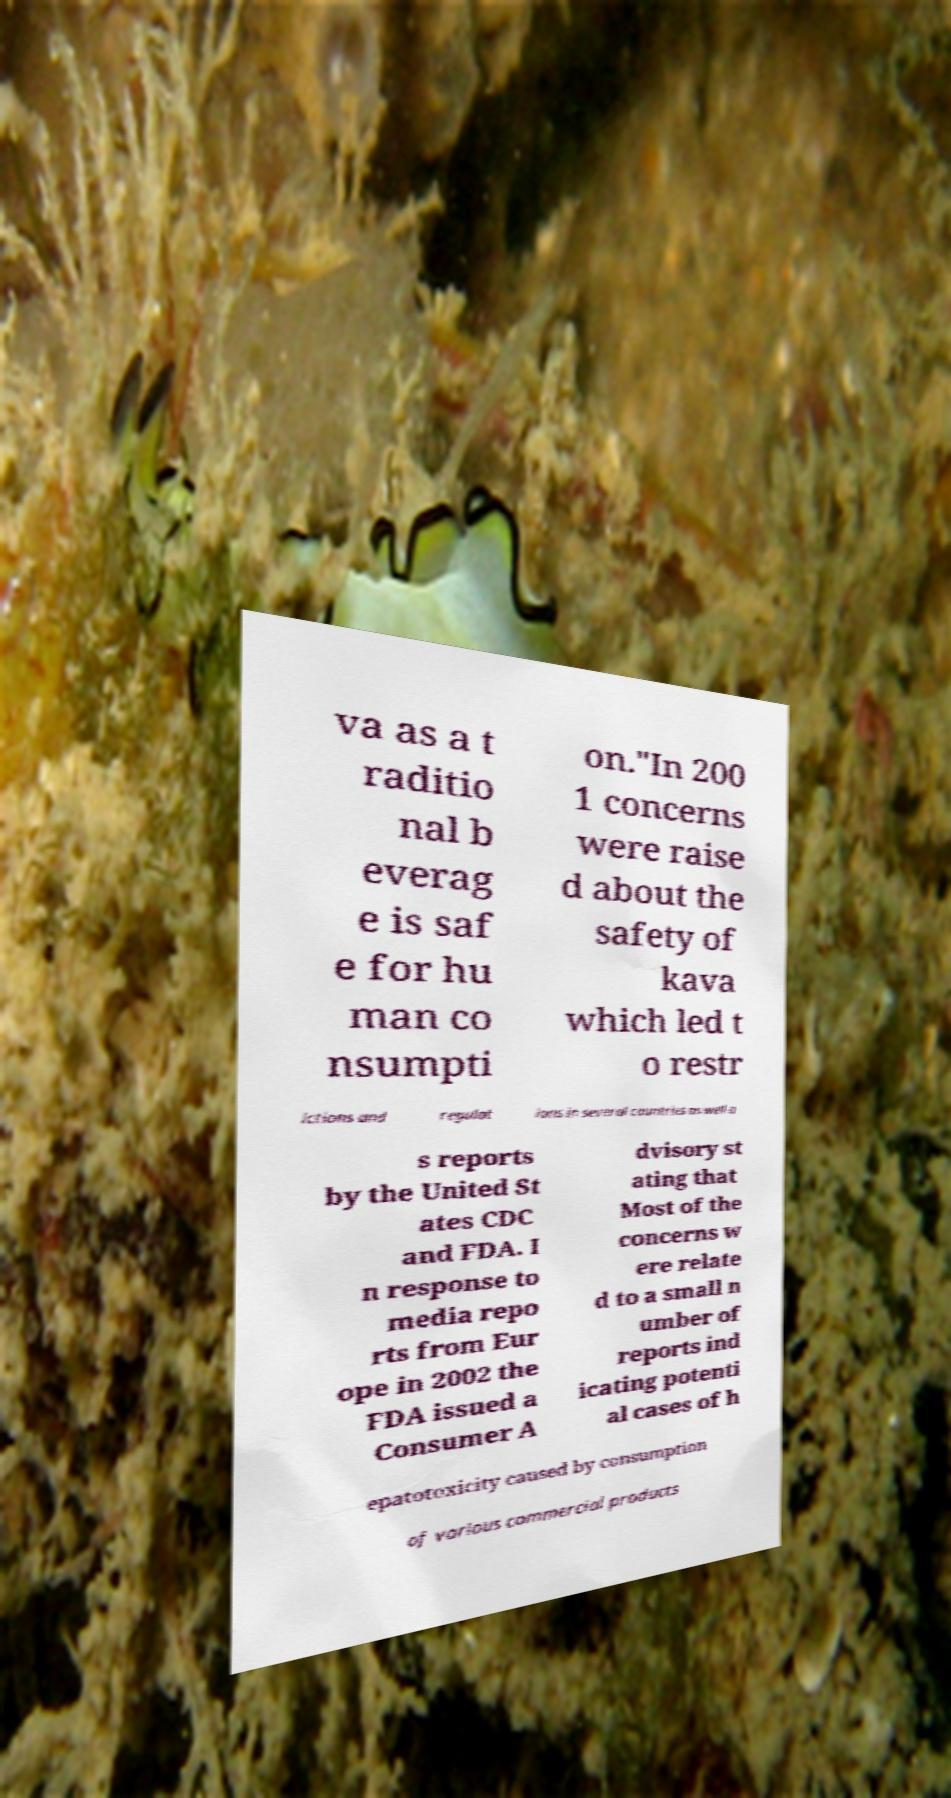Can you accurately transcribe the text from the provided image for me? va as a t raditio nal b everag e is saf e for hu man co nsumpti on."In 200 1 concerns were raise d about the safety of kava which led t o restr ictions and regulat ions in several countries as well a s reports by the United St ates CDC and FDA. I n response to media repo rts from Eur ope in 2002 the FDA issued a Consumer A dvisory st ating that Most of the concerns w ere relate d to a small n umber of reports ind icating potenti al cases of h epatotoxicity caused by consumption of various commercial products 